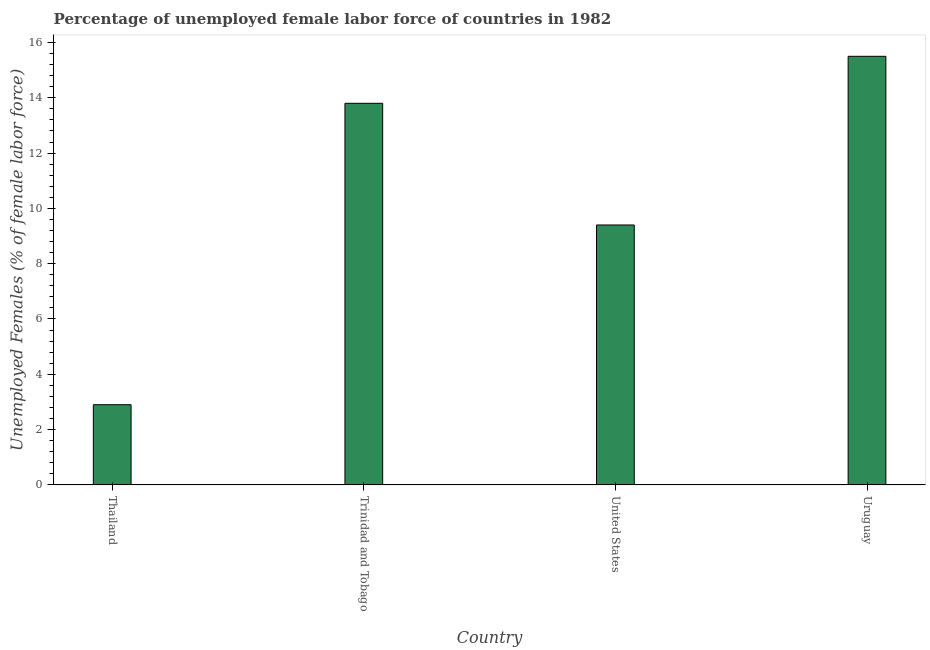Does the graph contain any zero values?
Keep it short and to the point. No. What is the title of the graph?
Make the answer very short. Percentage of unemployed female labor force of countries in 1982. What is the label or title of the X-axis?
Keep it short and to the point. Country. What is the label or title of the Y-axis?
Your answer should be very brief. Unemployed Females (% of female labor force). What is the total unemployed female labour force in Thailand?
Keep it short and to the point. 2.9. Across all countries, what is the minimum total unemployed female labour force?
Your response must be concise. 2.9. In which country was the total unemployed female labour force maximum?
Make the answer very short. Uruguay. In which country was the total unemployed female labour force minimum?
Keep it short and to the point. Thailand. What is the sum of the total unemployed female labour force?
Keep it short and to the point. 41.6. What is the difference between the total unemployed female labour force in Thailand and Uruguay?
Keep it short and to the point. -12.6. What is the median total unemployed female labour force?
Offer a terse response. 11.6. In how many countries, is the total unemployed female labour force greater than 4.8 %?
Ensure brevity in your answer.  3. What is the ratio of the total unemployed female labour force in Trinidad and Tobago to that in United States?
Offer a very short reply. 1.47. Is the total unemployed female labour force in Thailand less than that in Trinidad and Tobago?
Your answer should be compact. Yes. Is the difference between the total unemployed female labour force in Thailand and Trinidad and Tobago greater than the difference between any two countries?
Offer a terse response. No. What is the difference between the highest and the lowest total unemployed female labour force?
Provide a succinct answer. 12.6. In how many countries, is the total unemployed female labour force greater than the average total unemployed female labour force taken over all countries?
Your response must be concise. 2. What is the Unemployed Females (% of female labor force) of Thailand?
Give a very brief answer. 2.9. What is the Unemployed Females (% of female labor force) of Trinidad and Tobago?
Ensure brevity in your answer.  13.8. What is the Unemployed Females (% of female labor force) of United States?
Your answer should be very brief. 9.4. What is the difference between the Unemployed Females (% of female labor force) in Thailand and Uruguay?
Offer a terse response. -12.6. What is the difference between the Unemployed Females (% of female labor force) in Trinidad and Tobago and United States?
Your answer should be compact. 4.4. What is the difference between the Unemployed Females (% of female labor force) in Trinidad and Tobago and Uruguay?
Offer a terse response. -1.7. What is the difference between the Unemployed Females (% of female labor force) in United States and Uruguay?
Ensure brevity in your answer.  -6.1. What is the ratio of the Unemployed Females (% of female labor force) in Thailand to that in Trinidad and Tobago?
Keep it short and to the point. 0.21. What is the ratio of the Unemployed Females (% of female labor force) in Thailand to that in United States?
Make the answer very short. 0.31. What is the ratio of the Unemployed Females (% of female labor force) in Thailand to that in Uruguay?
Provide a succinct answer. 0.19. What is the ratio of the Unemployed Females (% of female labor force) in Trinidad and Tobago to that in United States?
Your answer should be very brief. 1.47. What is the ratio of the Unemployed Females (% of female labor force) in Trinidad and Tobago to that in Uruguay?
Offer a terse response. 0.89. What is the ratio of the Unemployed Females (% of female labor force) in United States to that in Uruguay?
Give a very brief answer. 0.61. 